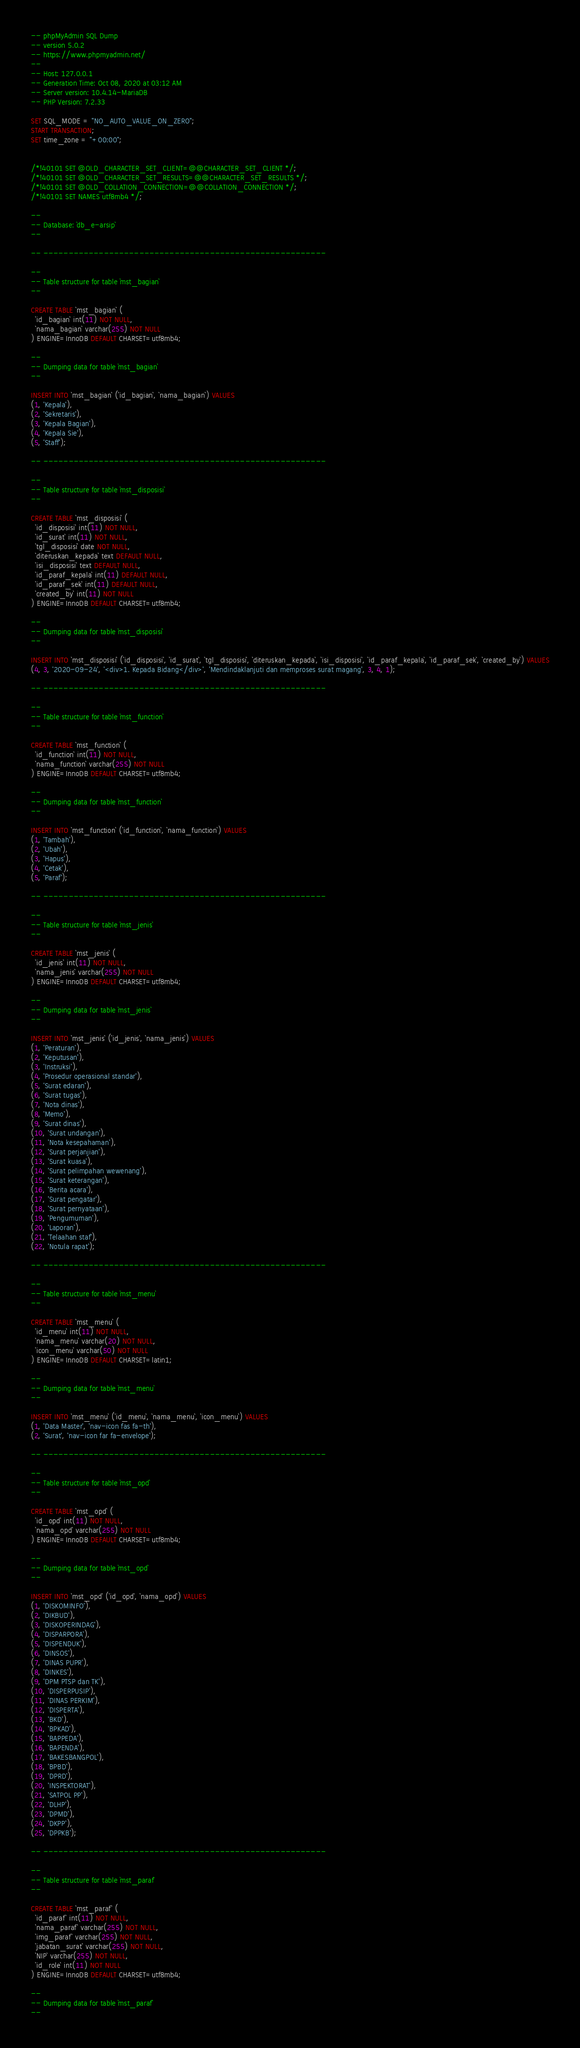Convert code to text. <code><loc_0><loc_0><loc_500><loc_500><_SQL_>-- phpMyAdmin SQL Dump
-- version 5.0.2
-- https://www.phpmyadmin.net/
--
-- Host: 127.0.0.1
-- Generation Time: Oct 08, 2020 at 03:12 AM
-- Server version: 10.4.14-MariaDB
-- PHP Version: 7.2.33

SET SQL_MODE = "NO_AUTO_VALUE_ON_ZERO";
START TRANSACTION;
SET time_zone = "+00:00";


/*!40101 SET @OLD_CHARACTER_SET_CLIENT=@@CHARACTER_SET_CLIENT */;
/*!40101 SET @OLD_CHARACTER_SET_RESULTS=@@CHARACTER_SET_RESULTS */;
/*!40101 SET @OLD_COLLATION_CONNECTION=@@COLLATION_CONNECTION */;
/*!40101 SET NAMES utf8mb4 */;

--
-- Database: `db_e-arsip`
--

-- --------------------------------------------------------

--
-- Table structure for table `mst_bagian`
--

CREATE TABLE `mst_bagian` (
  `id_bagian` int(11) NOT NULL,
  `nama_bagian` varchar(255) NOT NULL
) ENGINE=InnoDB DEFAULT CHARSET=utf8mb4;

--
-- Dumping data for table `mst_bagian`
--

INSERT INTO `mst_bagian` (`id_bagian`, `nama_bagian`) VALUES
(1, 'Kepala'),
(2, 'Sekretaris'),
(3, 'Kepala Bagian'),
(4, 'Kepala Sie'),
(5, 'Staff');

-- --------------------------------------------------------

--
-- Table structure for table `mst_disposisi`
--

CREATE TABLE `mst_disposisi` (
  `id_disposisi` int(11) NOT NULL,
  `id_surat` int(11) NOT NULL,
  `tgl_disposisi` date NOT NULL,
  `diteruskan_kepada` text DEFAULT NULL,
  `isi_disposisi` text DEFAULT NULL,
  `id_paraf_kepala` int(11) DEFAULT NULL,
  `id_paraf_sek` int(11) DEFAULT NULL,
  `created_by` int(11) NOT NULL
) ENGINE=InnoDB DEFAULT CHARSET=utf8mb4;

--
-- Dumping data for table `mst_disposisi`
--

INSERT INTO `mst_disposisi` (`id_disposisi`, `id_surat`, `tgl_disposisi`, `diteruskan_kepada`, `isi_disposisi`, `id_paraf_kepala`, `id_paraf_sek`, `created_by`) VALUES
(4, 3, '2020-09-24', '<div>1. Kepada Bidang</div>', 'Mendindaklanjuti dan memproses surat magang', 3, 4, 1);

-- --------------------------------------------------------

--
-- Table structure for table `mst_function`
--

CREATE TABLE `mst_function` (
  `id_function` int(11) NOT NULL,
  `nama_function` varchar(255) NOT NULL
) ENGINE=InnoDB DEFAULT CHARSET=utf8mb4;

--
-- Dumping data for table `mst_function`
--

INSERT INTO `mst_function` (`id_function`, `nama_function`) VALUES
(1, 'Tambah'),
(2, 'Ubah'),
(3, 'Hapus'),
(4, 'Cetak'),
(5, 'Paraf');

-- --------------------------------------------------------

--
-- Table structure for table `mst_jenis`
--

CREATE TABLE `mst_jenis` (
  `id_jenis` int(11) NOT NULL,
  `nama_jenis` varchar(255) NOT NULL
) ENGINE=InnoDB DEFAULT CHARSET=utf8mb4;

--
-- Dumping data for table `mst_jenis`
--

INSERT INTO `mst_jenis` (`id_jenis`, `nama_jenis`) VALUES
(1, 'Peraturan'),
(2, 'Keputusan'),
(3, 'Instruksi'),
(4, 'Prosedur operasional standar'),
(5, 'Surat edaran'),
(6, 'Surat tugas'),
(7, 'Nota dinas'),
(8, 'Memo'),
(9, 'Surat dinas'),
(10, 'Surat undangan'),
(11, 'Nota kesepahaman'),
(12, 'Surat perjanjian'),
(13, 'Surat kuasa'),
(14, 'Surat pelimpahan wewenang'),
(15, 'Surat keterangan'),
(16, 'Berita acara'),
(17, 'Surat pengatar'),
(18, 'Surat pernyataan'),
(19, 'Pengumuman'),
(20, 'Laporan'),
(21, 'Telaahan staf'),
(22, 'Notula rapat');

-- --------------------------------------------------------

--
-- Table structure for table `mst_menu`
--

CREATE TABLE `mst_menu` (
  `id_menu` int(11) NOT NULL,
  `nama_menu` varchar(20) NOT NULL,
  `icon_menu` varchar(50) NOT NULL
) ENGINE=InnoDB DEFAULT CHARSET=latin1;

--
-- Dumping data for table `mst_menu`
--

INSERT INTO `mst_menu` (`id_menu`, `nama_menu`, `icon_menu`) VALUES
(1, 'Data Master', 'nav-icon fas fa-th'),
(2, 'Surat', 'nav-icon far fa-envelope');

-- --------------------------------------------------------

--
-- Table structure for table `mst_opd`
--

CREATE TABLE `mst_opd` (
  `id_opd` int(11) NOT NULL,
  `nama_opd` varchar(255) NOT NULL
) ENGINE=InnoDB DEFAULT CHARSET=utf8mb4;

--
-- Dumping data for table `mst_opd`
--

INSERT INTO `mst_opd` (`id_opd`, `nama_opd`) VALUES
(1, 'DISKOMINFO'),
(2, 'DIKBUD'),
(3, 'DISKOPERINDAG'),
(4, 'DISPARPORA'),
(5, 'DISPENDUK'),
(6, 'DINSOS'),
(7, 'DINAS PUPR'),
(8, 'DINKES'),
(9, 'DPM PTSP dan TK'),
(10, 'DISPERPUSIP'),
(11, 'DINAS PERKIM'),
(12, 'DISPERTA'),
(13, 'BKD'),
(14, 'BPKAD'),
(15, 'BAPPEDA'),
(16, 'BAPENDA'),
(17, 'BAKESBANGPOL'),
(18, 'BPBD'),
(19, 'DPRD'),
(20, 'INSPEKTORAT'),
(21, 'SATPOL PP'),
(22, 'DLHP'),
(23, 'DPMD'),
(24, 'DKPP'),
(25, 'DPPKB');

-- --------------------------------------------------------

--
-- Table structure for table `mst_paraf`
--

CREATE TABLE `mst_paraf` (
  `id_paraf` int(11) NOT NULL,
  `nama_paraf` varchar(255) NOT NULL,
  `img_paraf` varchar(255) NOT NULL,
  `jabatan_surat` varchar(255) NOT NULL,
  `NIP` varchar(255) NOT NULL,
  `id_role` int(11) NOT NULL
) ENGINE=InnoDB DEFAULT CHARSET=utf8mb4;

--
-- Dumping data for table `mst_paraf`
--
</code> 